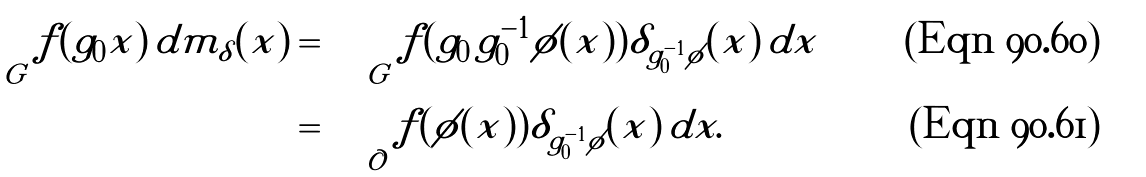Convert formula to latex. <formula><loc_0><loc_0><loc_500><loc_500>\int _ { G } f ( g _ { 0 } x ) \, d m _ { \delta } ( x ) & = \int _ { G } f ( g _ { 0 } \, g _ { 0 } ^ { - 1 } \phi ( x ) ) \delta _ { g _ { 0 } ^ { - 1 } \phi } ( x ) \, d x \\ & = \int _ { \mathcal { O } } f ( \phi ( x ) ) \delta _ { g _ { 0 } ^ { - 1 } \phi } ( x ) \, d x .</formula> 